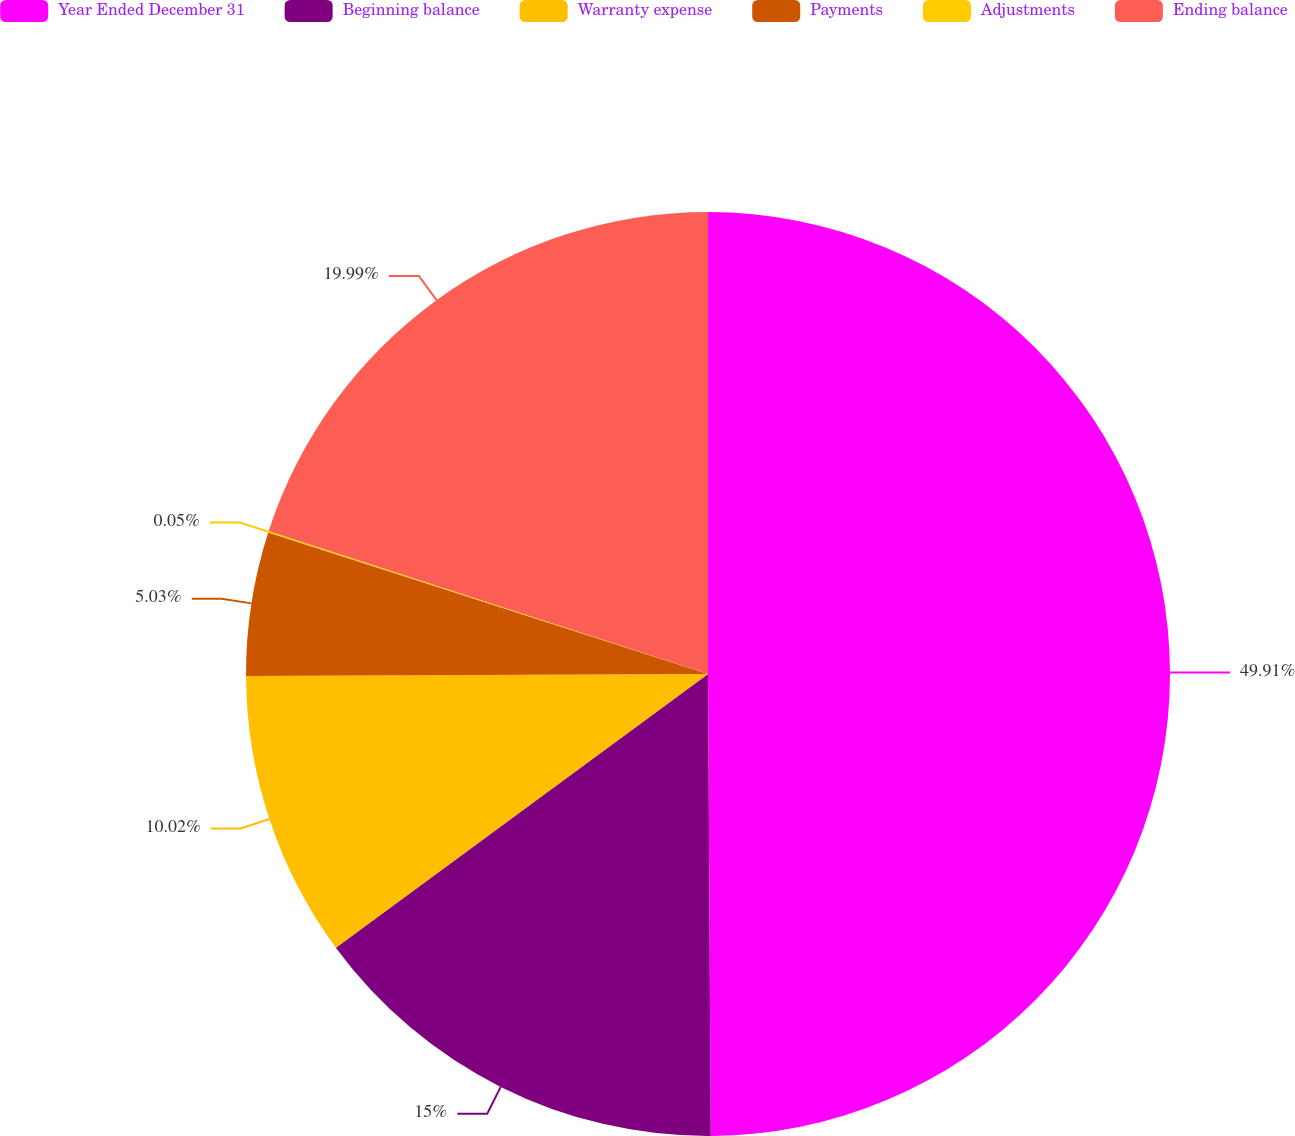Convert chart. <chart><loc_0><loc_0><loc_500><loc_500><pie_chart><fcel>Year Ended December 31<fcel>Beginning balance<fcel>Warranty expense<fcel>Payments<fcel>Adjustments<fcel>Ending balance<nl><fcel>49.9%<fcel>15.0%<fcel>10.02%<fcel>5.03%<fcel>0.05%<fcel>19.99%<nl></chart> 